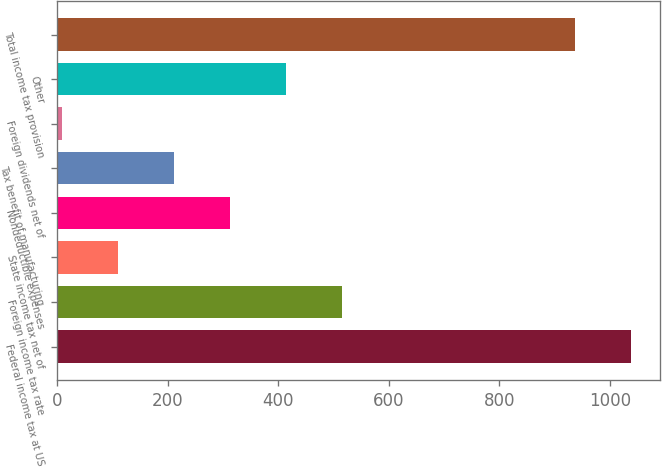<chart> <loc_0><loc_0><loc_500><loc_500><bar_chart><fcel>Federal income tax at US<fcel>Foreign income tax rate<fcel>State income tax net of<fcel>Nondeductible expenses<fcel>Tax benefit of manufacturing<fcel>Foreign dividends net of<fcel>Other<fcel>Total income tax provision<nl><fcel>1038.4<fcel>516<fcel>110.4<fcel>313.2<fcel>211.8<fcel>9<fcel>414.6<fcel>937<nl></chart> 